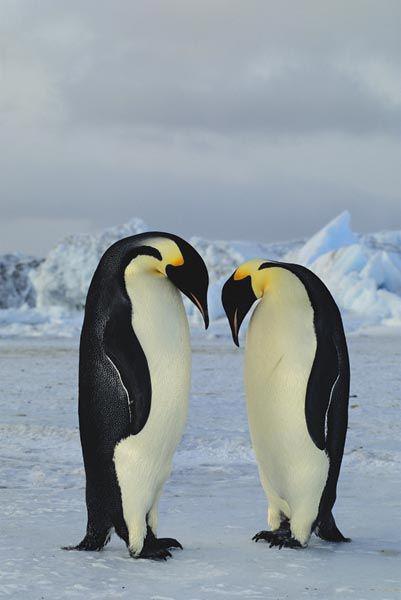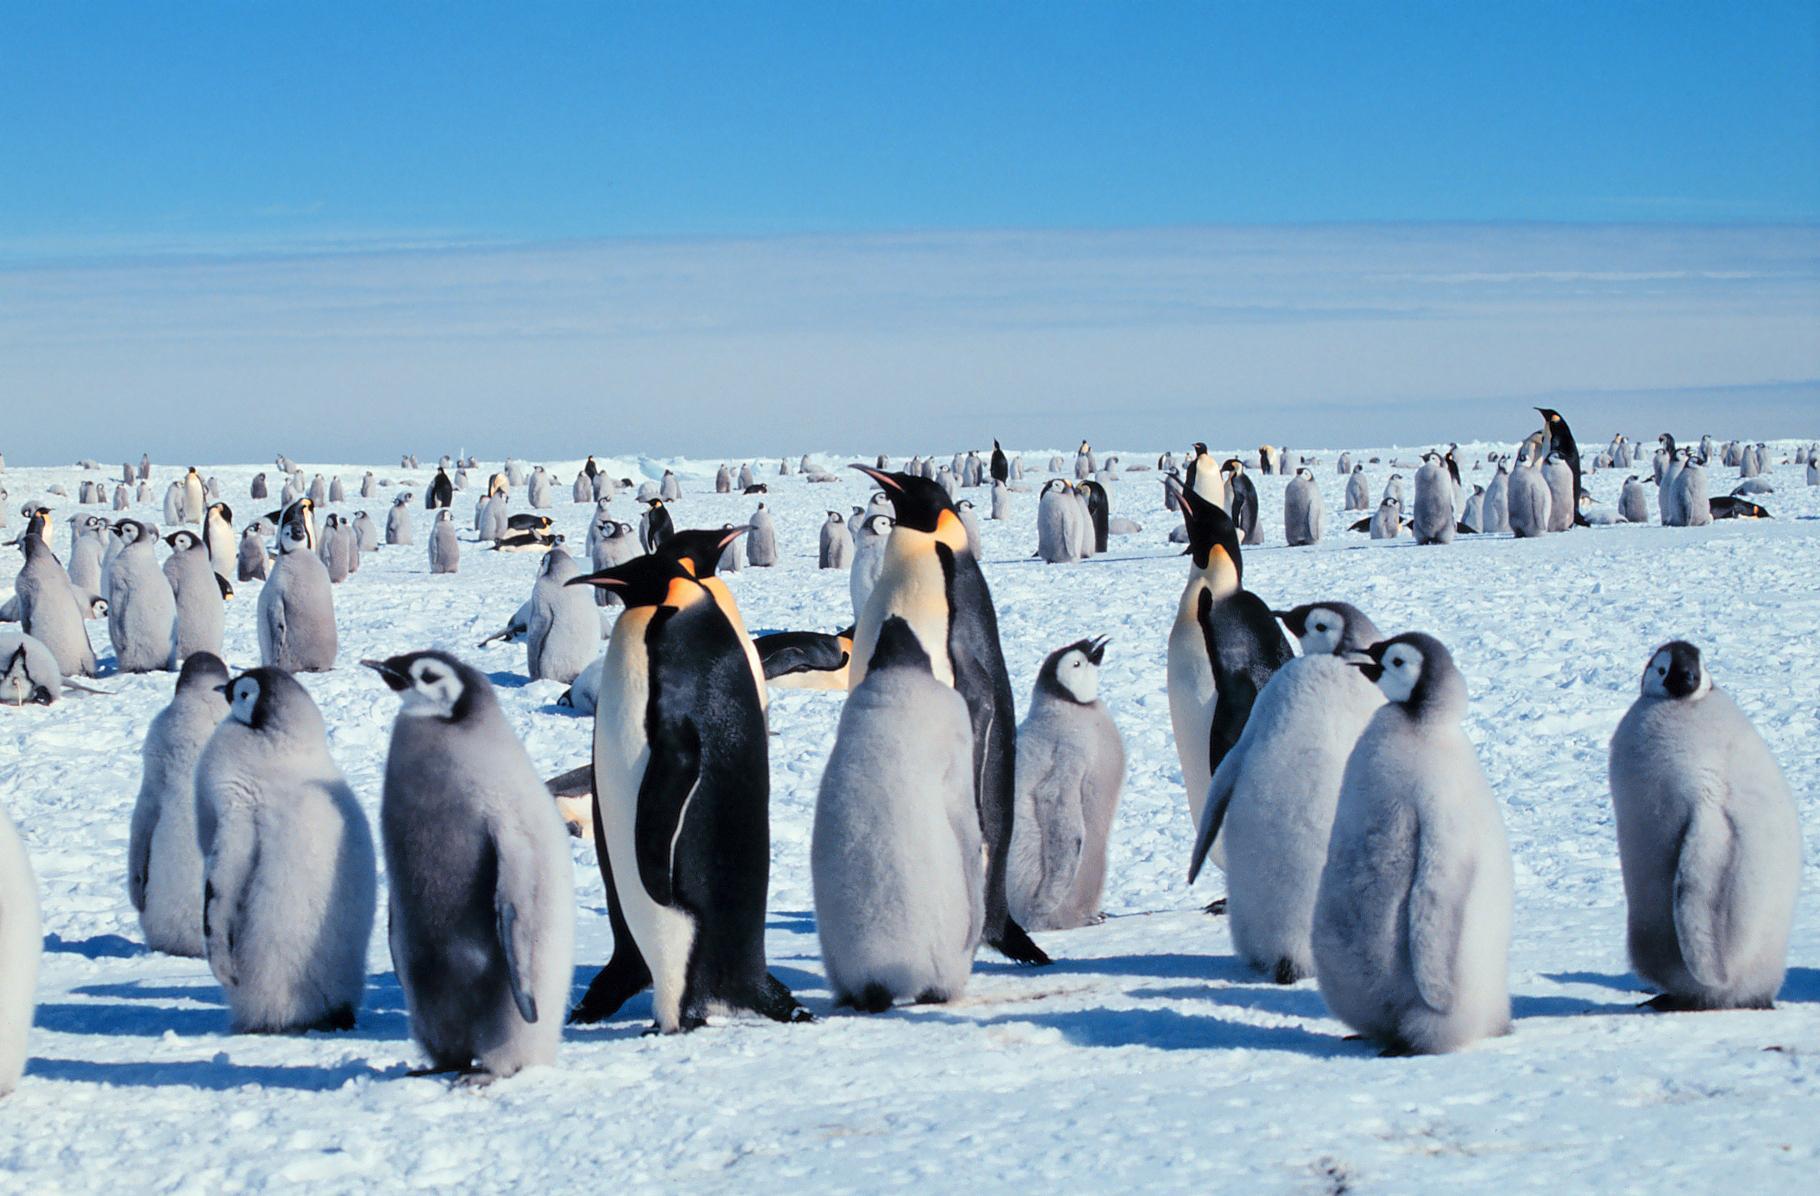The first image is the image on the left, the second image is the image on the right. For the images displayed, is the sentence "There is at least one image containing only two penguins." factually correct? Answer yes or no. Yes. The first image is the image on the left, the second image is the image on the right. Analyze the images presented: Is the assertion "There are two penguins standing together in the left image." valid? Answer yes or no. Yes. 